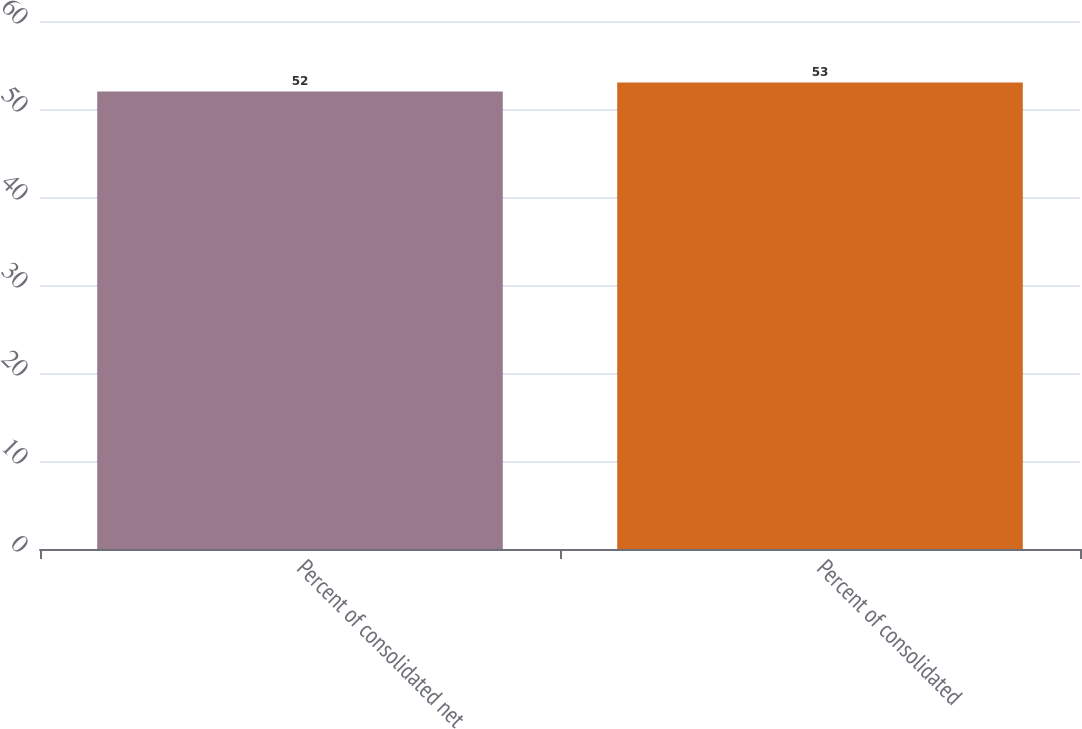<chart> <loc_0><loc_0><loc_500><loc_500><bar_chart><fcel>Percent of consolidated net<fcel>Percent of consolidated<nl><fcel>52<fcel>53<nl></chart> 